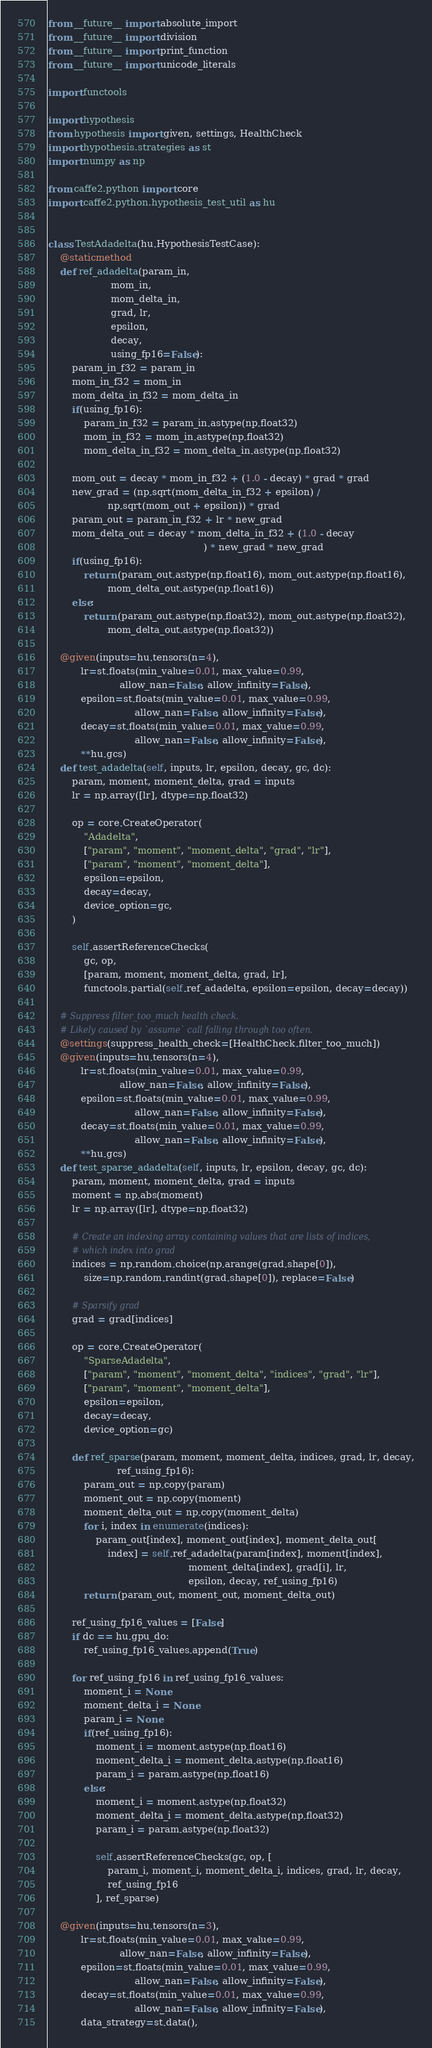<code> <loc_0><loc_0><loc_500><loc_500><_Python_>from __future__ import absolute_import
from __future__ import division
from __future__ import print_function
from __future__ import unicode_literals

import functools

import hypothesis
from hypothesis import given, settings, HealthCheck
import hypothesis.strategies as st
import numpy as np

from caffe2.python import core
import caffe2.python.hypothesis_test_util as hu


class TestAdadelta(hu.HypothesisTestCase):
    @staticmethod
    def ref_adadelta(param_in,
                     mom_in,
                     mom_delta_in,
                     grad, lr,
                     epsilon,
                     decay,
                     using_fp16=False):
        param_in_f32 = param_in
        mom_in_f32 = mom_in
        mom_delta_in_f32 = mom_delta_in
        if(using_fp16):
            param_in_f32 = param_in.astype(np.float32)
            mom_in_f32 = mom_in.astype(np.float32)
            mom_delta_in_f32 = mom_delta_in.astype(np.float32)

        mom_out = decay * mom_in_f32 + (1.0 - decay) * grad * grad
        new_grad = (np.sqrt(mom_delta_in_f32 + epsilon) /
                    np.sqrt(mom_out + epsilon)) * grad
        param_out = param_in_f32 + lr * new_grad
        mom_delta_out = decay * mom_delta_in_f32 + (1.0 - decay
                                                    ) * new_grad * new_grad
        if(using_fp16):
            return (param_out.astype(np.float16), mom_out.astype(np.float16),
                    mom_delta_out.astype(np.float16))
        else:
            return (param_out.astype(np.float32), mom_out.astype(np.float32),
                    mom_delta_out.astype(np.float32))

    @given(inputs=hu.tensors(n=4),
           lr=st.floats(min_value=0.01, max_value=0.99,
                        allow_nan=False, allow_infinity=False),
           epsilon=st.floats(min_value=0.01, max_value=0.99,
                             allow_nan=False, allow_infinity=False),
           decay=st.floats(min_value=0.01, max_value=0.99,
                             allow_nan=False, allow_infinity=False),
           **hu.gcs)
    def test_adadelta(self, inputs, lr, epsilon, decay, gc, dc):
        param, moment, moment_delta, grad = inputs
        lr = np.array([lr], dtype=np.float32)

        op = core.CreateOperator(
            "Adadelta",
            ["param", "moment", "moment_delta", "grad", "lr"],
            ["param", "moment", "moment_delta"],
            epsilon=epsilon,
            decay=decay,
            device_option=gc,
        )

        self.assertReferenceChecks(
            gc, op,
            [param, moment, moment_delta, grad, lr],
            functools.partial(self.ref_adadelta, epsilon=epsilon, decay=decay))

    # Suppress filter_too_much health check.
    # Likely caused by `assume` call falling through too often.
    @settings(suppress_health_check=[HealthCheck.filter_too_much])
    @given(inputs=hu.tensors(n=4),
           lr=st.floats(min_value=0.01, max_value=0.99,
                        allow_nan=False, allow_infinity=False),
           epsilon=st.floats(min_value=0.01, max_value=0.99,
                             allow_nan=False, allow_infinity=False),
           decay=st.floats(min_value=0.01, max_value=0.99,
                             allow_nan=False, allow_infinity=False),
           **hu.gcs)
    def test_sparse_adadelta(self, inputs, lr, epsilon, decay, gc, dc):
        param, moment, moment_delta, grad = inputs
        moment = np.abs(moment)
        lr = np.array([lr], dtype=np.float32)

        # Create an indexing array containing values that are lists of indices,
        # which index into grad
        indices = np.random.choice(np.arange(grad.shape[0]),
            size=np.random.randint(grad.shape[0]), replace=False)

        # Sparsify grad
        grad = grad[indices]

        op = core.CreateOperator(
            "SparseAdadelta",
            ["param", "moment", "moment_delta", "indices", "grad", "lr"],
            ["param", "moment", "moment_delta"],
            epsilon=epsilon,
            decay=decay,
            device_option=gc)

        def ref_sparse(param, moment, moment_delta, indices, grad, lr, decay,
                       ref_using_fp16):
            param_out = np.copy(param)
            moment_out = np.copy(moment)
            moment_delta_out = np.copy(moment_delta)
            for i, index in enumerate(indices):
                param_out[index], moment_out[index], moment_delta_out[
                    index] = self.ref_adadelta(param[index], moment[index],
                                               moment_delta[index], grad[i], lr,
                                               epsilon, decay, ref_using_fp16)
            return (param_out, moment_out, moment_delta_out)

        ref_using_fp16_values = [False]
        if dc == hu.gpu_do:
            ref_using_fp16_values.append(True)

        for ref_using_fp16 in ref_using_fp16_values:
            moment_i = None
            moment_delta_i = None
            param_i = None
            if(ref_using_fp16):
                moment_i = moment.astype(np.float16)
                moment_delta_i = moment_delta.astype(np.float16)
                param_i = param.astype(np.float16)
            else:
                moment_i = moment.astype(np.float32)
                moment_delta_i = moment_delta.astype(np.float32)
                param_i = param.astype(np.float32)

                self.assertReferenceChecks(gc, op, [
                    param_i, moment_i, moment_delta_i, indices, grad, lr, decay,
                    ref_using_fp16
                ], ref_sparse)

    @given(inputs=hu.tensors(n=3),
           lr=st.floats(min_value=0.01, max_value=0.99,
                        allow_nan=False, allow_infinity=False),
           epsilon=st.floats(min_value=0.01, max_value=0.99,
                             allow_nan=False, allow_infinity=False),
           decay=st.floats(min_value=0.01, max_value=0.99,
                             allow_nan=False, allow_infinity=False),
           data_strategy=st.data(),</code> 